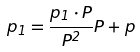<formula> <loc_0><loc_0><loc_500><loc_500>p _ { 1 } = \frac { p _ { 1 } \cdot P } { P ^ { 2 } } P + p</formula> 